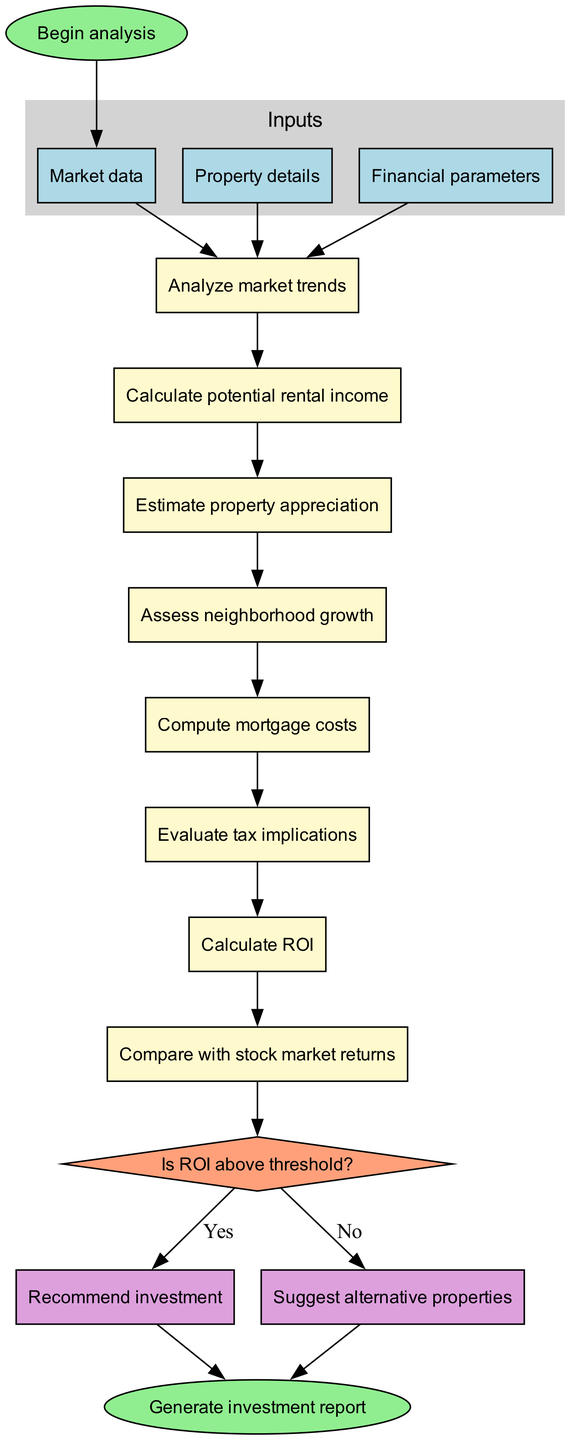What are the inputs to the algorithm? The diagram lists three inputs: Market data, Property details, and Financial parameters. These inputs are represented in the input cluster of the flowchart.
Answer: Market data, Property details, Financial parameters How many processes are involved in the algorithm? There are eight distinct processes shown in the processes section of the diagram that make up the algorithm's workflow.
Answer: 8 What is the decision point in the flowchart? The diagram indicates the decision point is "Is ROI above threshold?", which guides the flow based on the return on investment calculated.
Answer: Is ROI above threshold? What happens if the answer to the decision is 'Yes'? If the answer to the decision "Is ROI above threshold?" is 'Yes', the flowchart indicates that the output will be "Recommend investment," leading to the end of the process.
Answer: Recommend investment What is the last step in the algorithm? The flowchart indicates that the final step in the algorithm is "Generate investment report," which is reached after either recommending an investment or suggesting alternatives.
Answer: Generate investment report How do the processes relate to each other? The processes are sequentially connected; after the completion of each process in the flowchart, the next process begins, demonstrating the order of operations within the algorithm.
Answer: Sequentially connected What happens when ROI is below the threshold? When the ROI is below the threshold, the flowchart dictates that the alternate output "Suggest alternative properties" is generated, which also leads to the end of the process.
Answer: Suggest alternative properties Which process involves calculating rental income? The process labeled "Calculate potential rental income" specifically addresses the computation of expected rental income from the property, following the analysis of market trends.
Answer: Calculate potential rental income 